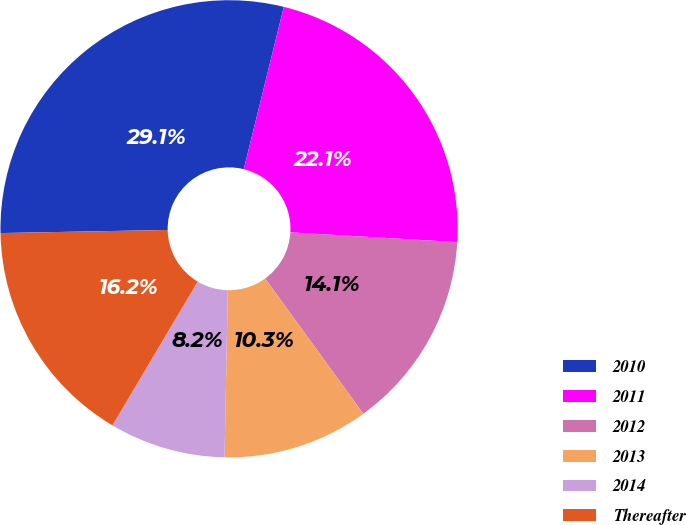<chart> <loc_0><loc_0><loc_500><loc_500><pie_chart><fcel>2010<fcel>2011<fcel>2012<fcel>2013<fcel>2014<fcel>Thereafter<nl><fcel>29.15%<fcel>22.08%<fcel>14.08%<fcel>10.31%<fcel>8.21%<fcel>16.18%<nl></chart> 